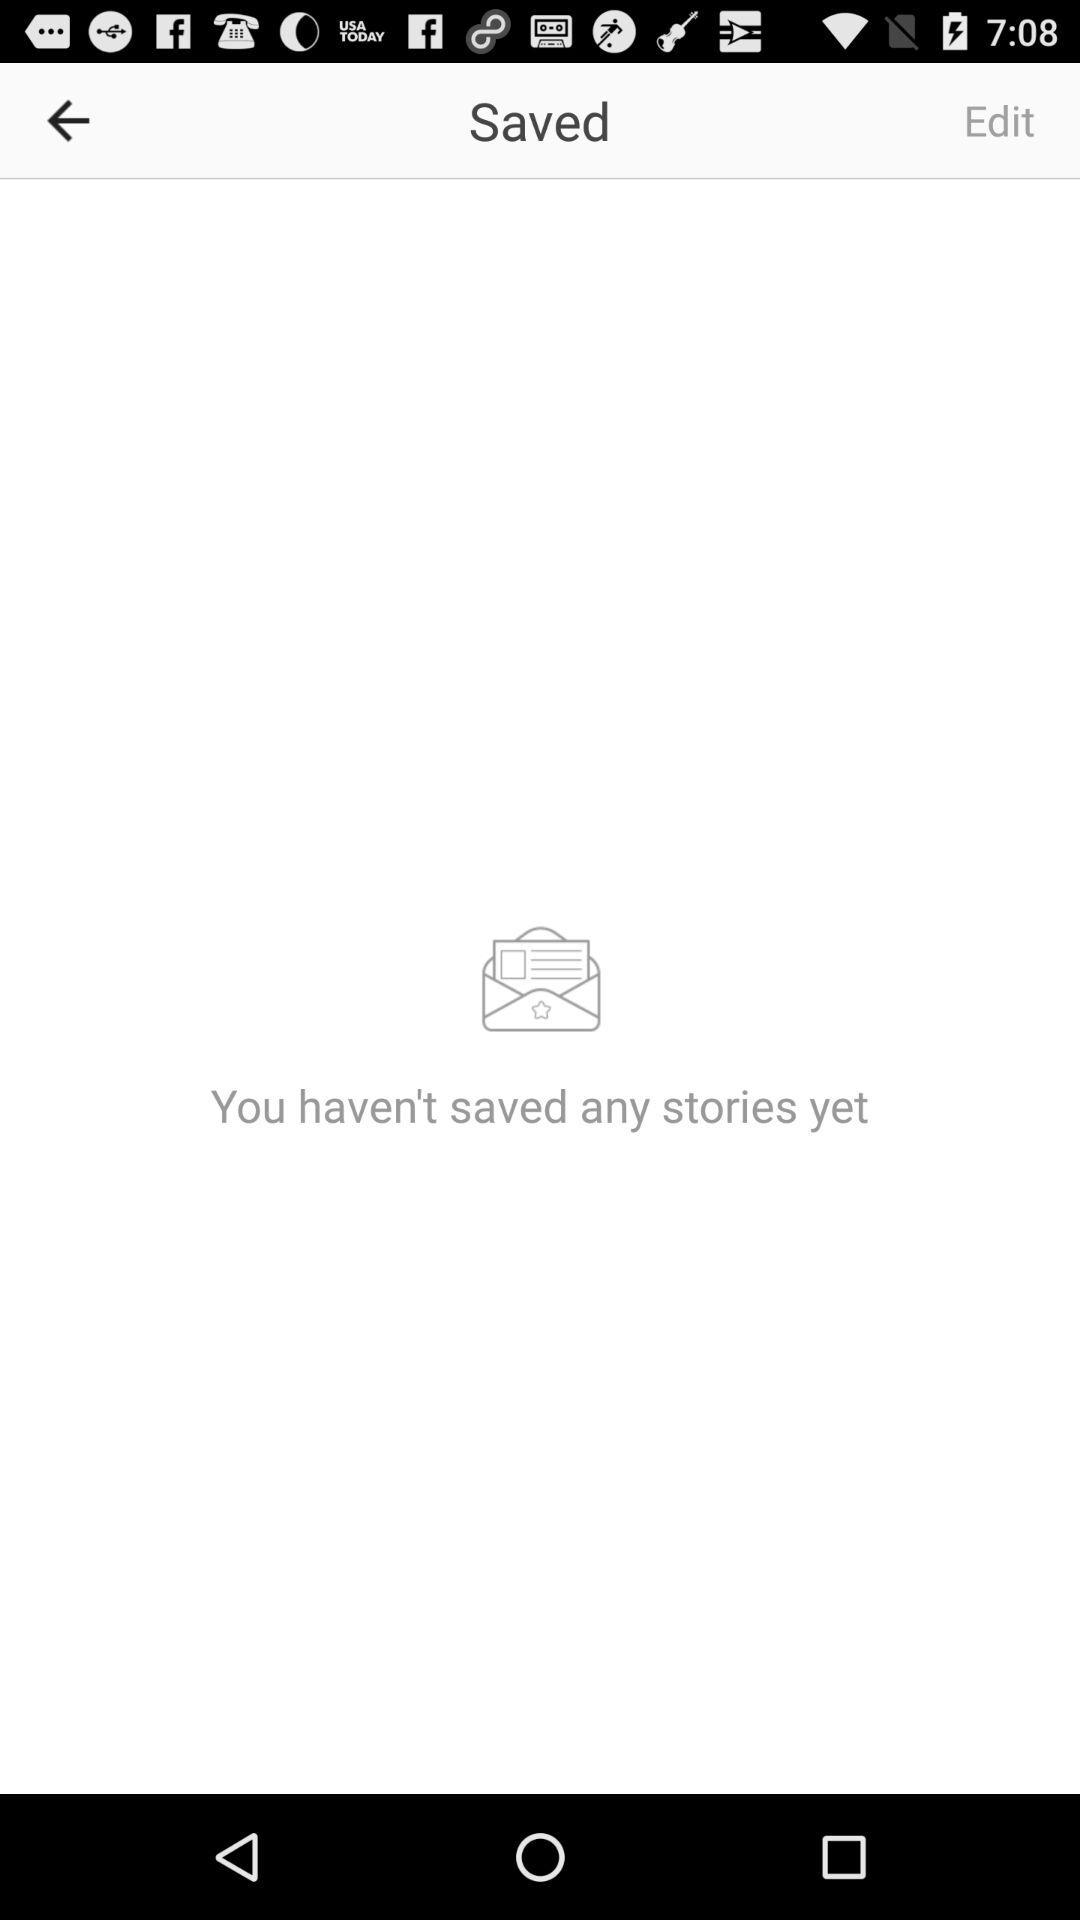How many stories have you saved?
Answer the question using a single word or phrase. 0 